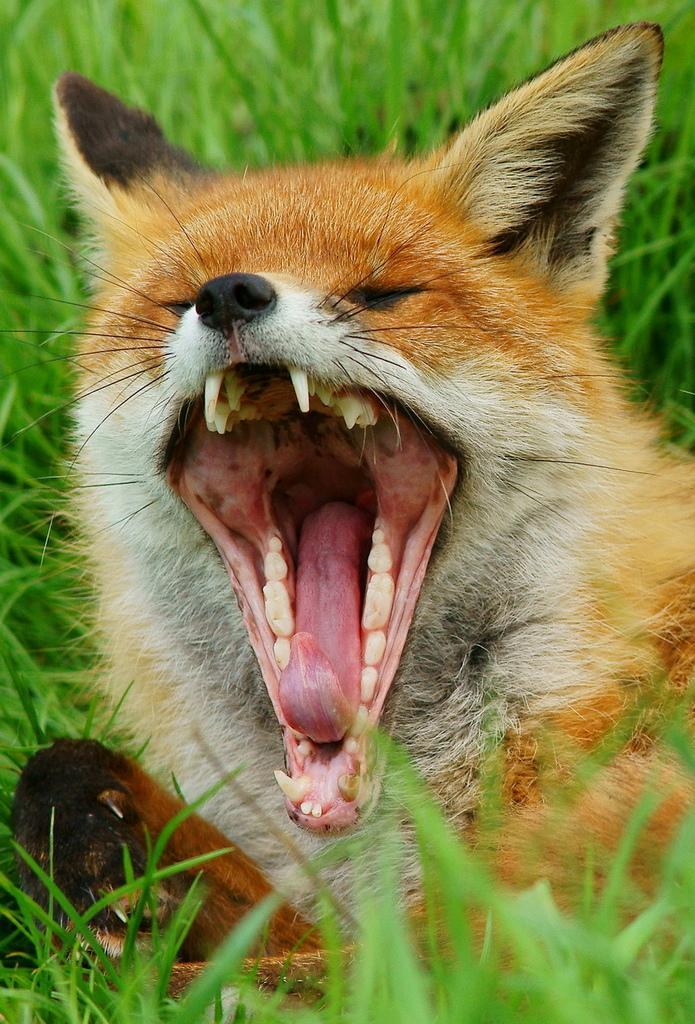In one or two sentences, can you explain what this image depicts? A red fox is present on the grass and yawning. 